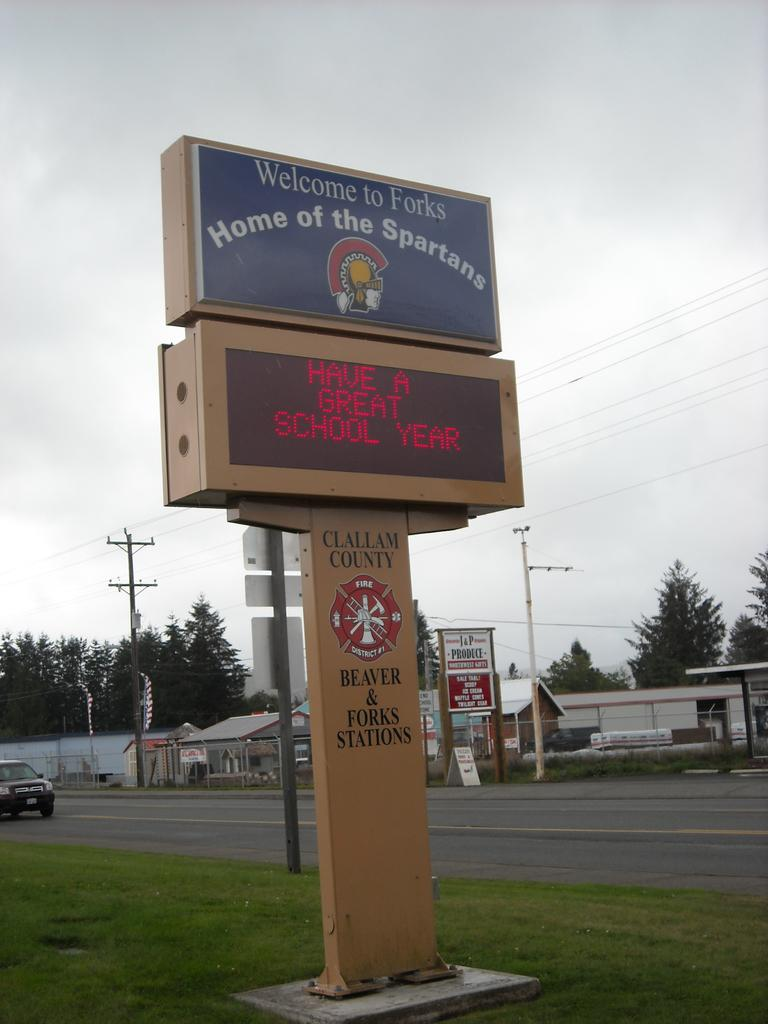<image>
Relay a brief, clear account of the picture shown. A digital sign by the street says have a great school year. 